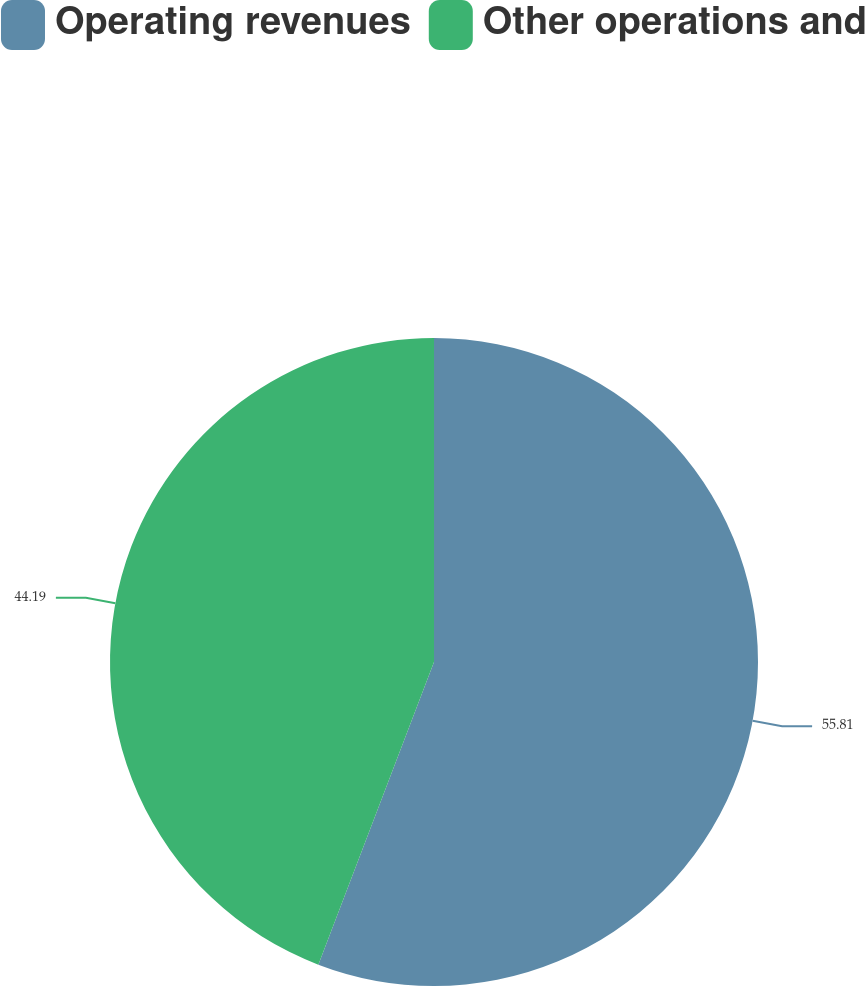Convert chart. <chart><loc_0><loc_0><loc_500><loc_500><pie_chart><fcel>Operating revenues<fcel>Other operations and<nl><fcel>55.81%<fcel>44.19%<nl></chart> 